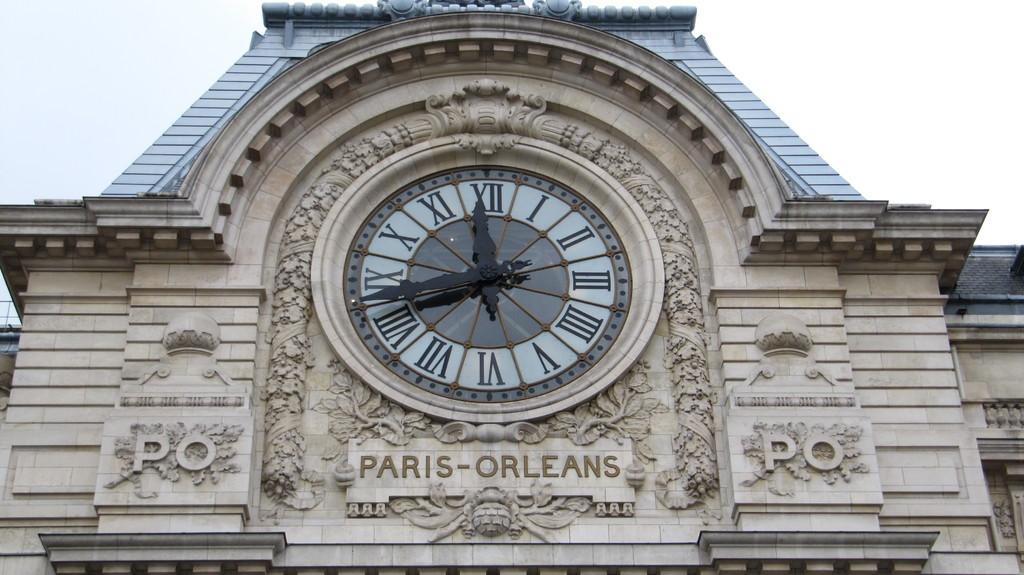<image>
Present a compact description of the photo's key features. A large clock shows the time in Paris-Orleans. 